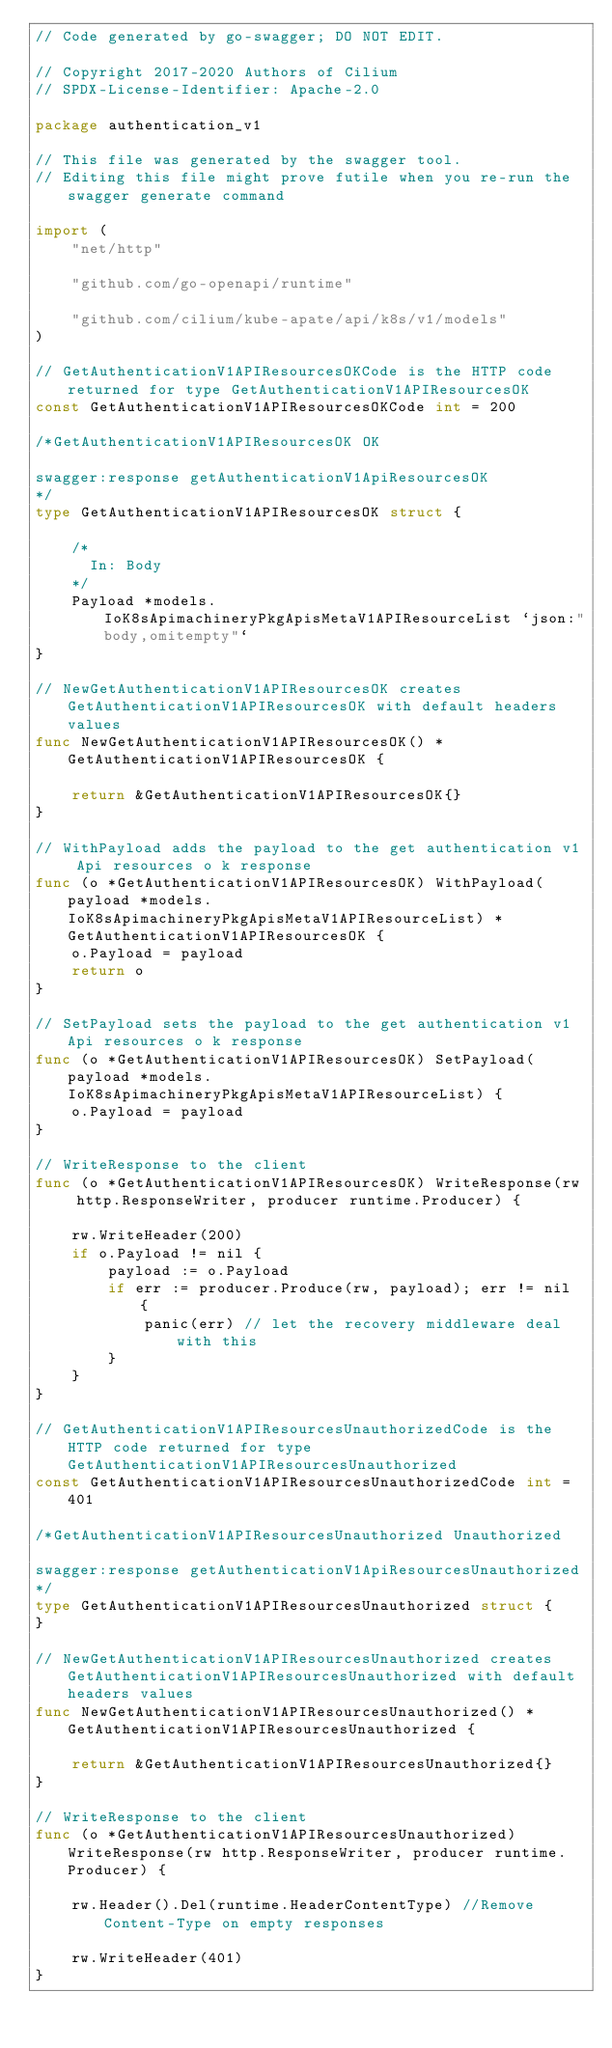<code> <loc_0><loc_0><loc_500><loc_500><_Go_>// Code generated by go-swagger; DO NOT EDIT.

// Copyright 2017-2020 Authors of Cilium
// SPDX-License-Identifier: Apache-2.0

package authentication_v1

// This file was generated by the swagger tool.
// Editing this file might prove futile when you re-run the swagger generate command

import (
	"net/http"

	"github.com/go-openapi/runtime"

	"github.com/cilium/kube-apate/api/k8s/v1/models"
)

// GetAuthenticationV1APIResourcesOKCode is the HTTP code returned for type GetAuthenticationV1APIResourcesOK
const GetAuthenticationV1APIResourcesOKCode int = 200

/*GetAuthenticationV1APIResourcesOK OK

swagger:response getAuthenticationV1ApiResourcesOK
*/
type GetAuthenticationV1APIResourcesOK struct {

	/*
	  In: Body
	*/
	Payload *models.IoK8sApimachineryPkgApisMetaV1APIResourceList `json:"body,omitempty"`
}

// NewGetAuthenticationV1APIResourcesOK creates GetAuthenticationV1APIResourcesOK with default headers values
func NewGetAuthenticationV1APIResourcesOK() *GetAuthenticationV1APIResourcesOK {

	return &GetAuthenticationV1APIResourcesOK{}
}

// WithPayload adds the payload to the get authentication v1 Api resources o k response
func (o *GetAuthenticationV1APIResourcesOK) WithPayload(payload *models.IoK8sApimachineryPkgApisMetaV1APIResourceList) *GetAuthenticationV1APIResourcesOK {
	o.Payload = payload
	return o
}

// SetPayload sets the payload to the get authentication v1 Api resources o k response
func (o *GetAuthenticationV1APIResourcesOK) SetPayload(payload *models.IoK8sApimachineryPkgApisMetaV1APIResourceList) {
	o.Payload = payload
}

// WriteResponse to the client
func (o *GetAuthenticationV1APIResourcesOK) WriteResponse(rw http.ResponseWriter, producer runtime.Producer) {

	rw.WriteHeader(200)
	if o.Payload != nil {
		payload := o.Payload
		if err := producer.Produce(rw, payload); err != nil {
			panic(err) // let the recovery middleware deal with this
		}
	}
}

// GetAuthenticationV1APIResourcesUnauthorizedCode is the HTTP code returned for type GetAuthenticationV1APIResourcesUnauthorized
const GetAuthenticationV1APIResourcesUnauthorizedCode int = 401

/*GetAuthenticationV1APIResourcesUnauthorized Unauthorized

swagger:response getAuthenticationV1ApiResourcesUnauthorized
*/
type GetAuthenticationV1APIResourcesUnauthorized struct {
}

// NewGetAuthenticationV1APIResourcesUnauthorized creates GetAuthenticationV1APIResourcesUnauthorized with default headers values
func NewGetAuthenticationV1APIResourcesUnauthorized() *GetAuthenticationV1APIResourcesUnauthorized {

	return &GetAuthenticationV1APIResourcesUnauthorized{}
}

// WriteResponse to the client
func (o *GetAuthenticationV1APIResourcesUnauthorized) WriteResponse(rw http.ResponseWriter, producer runtime.Producer) {

	rw.Header().Del(runtime.HeaderContentType) //Remove Content-Type on empty responses

	rw.WriteHeader(401)
}
</code> 